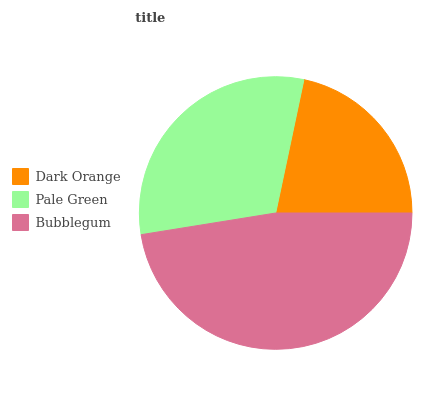Is Dark Orange the minimum?
Answer yes or no. Yes. Is Bubblegum the maximum?
Answer yes or no. Yes. Is Pale Green the minimum?
Answer yes or no. No. Is Pale Green the maximum?
Answer yes or no. No. Is Pale Green greater than Dark Orange?
Answer yes or no. Yes. Is Dark Orange less than Pale Green?
Answer yes or no. Yes. Is Dark Orange greater than Pale Green?
Answer yes or no. No. Is Pale Green less than Dark Orange?
Answer yes or no. No. Is Pale Green the high median?
Answer yes or no. Yes. Is Pale Green the low median?
Answer yes or no. Yes. Is Dark Orange the high median?
Answer yes or no. No. Is Dark Orange the low median?
Answer yes or no. No. 